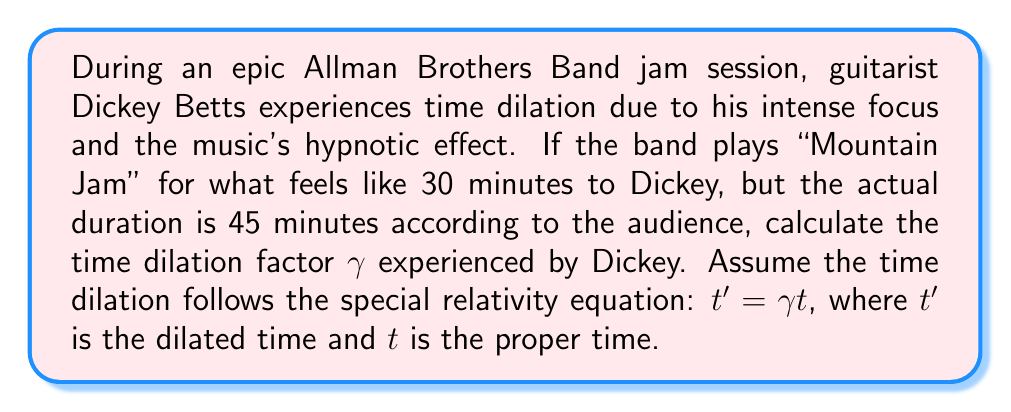Provide a solution to this math problem. To solve this problem, we'll use the time dilation equation from special relativity:

$$ t' = \gamma t $$

Where:
$t'$ = dilated time (time experienced by Dickey)
$\gamma$ = time dilation factor
$t$ = proper time (time measured by the audience)

We know:
$t' = 30$ minutes (Dickey's perceived time)
$t = 45$ minutes (actual time measured by the audience)

Substituting these values into the equation:

$$ 30 = \gamma \cdot 45 $$

To find $\gamma$, we divide both sides by 45:

$$ \gamma = \frac{30}{45} = \frac{2}{3} \approx 0.6667 $$

This means that for Dickey, time is passing more slowly than for the audience. The time dilation factor of approximately 0.6667 indicates that Dickey experiences about 66.67% of the time that passes for the audience.

To verify:
$$ t' = \gamma t = 0.6667 \cdot 45 = 30 \text{ minutes} $$

This matches Dickey's perceived duration of the jam session.
Answer: The time dilation factor $\gamma$ experienced by Dickey Betts during the jam session is $\frac{2}{3}$ or approximately 0.6667. 